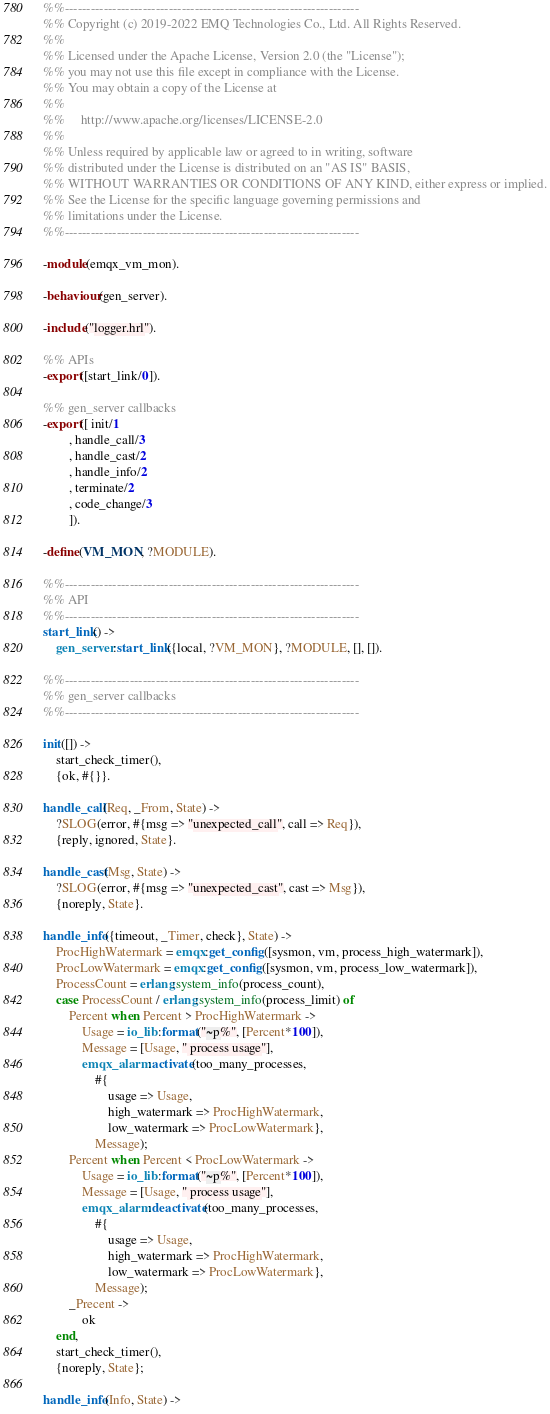Convert code to text. <code><loc_0><loc_0><loc_500><loc_500><_Erlang_>%%--------------------------------------------------------------------
%% Copyright (c) 2019-2022 EMQ Technologies Co., Ltd. All Rights Reserved.
%%
%% Licensed under the Apache License, Version 2.0 (the "License");
%% you may not use this file except in compliance with the License.
%% You may obtain a copy of the License at
%%
%%     http://www.apache.org/licenses/LICENSE-2.0
%%
%% Unless required by applicable law or agreed to in writing, software
%% distributed under the License is distributed on an "AS IS" BASIS,
%% WITHOUT WARRANTIES OR CONDITIONS OF ANY KIND, either express or implied.
%% See the License for the specific language governing permissions and
%% limitations under the License.
%%--------------------------------------------------------------------

-module(emqx_vm_mon).

-behaviour(gen_server).

-include("logger.hrl").

%% APIs
-export([start_link/0]).

%% gen_server callbacks
-export([ init/1
        , handle_call/3
        , handle_cast/2
        , handle_info/2
        , terminate/2
        , code_change/3
        ]).

-define(VM_MON, ?MODULE).

%%--------------------------------------------------------------------
%% API
%%--------------------------------------------------------------------
start_link() ->
    gen_server:start_link({local, ?VM_MON}, ?MODULE, [], []).

%%--------------------------------------------------------------------
%% gen_server callbacks
%%--------------------------------------------------------------------

init([]) ->
    start_check_timer(),
    {ok, #{}}.

handle_call(Req, _From, State) ->
    ?SLOG(error, #{msg => "unexpected_call", call => Req}),
    {reply, ignored, State}.

handle_cast(Msg, State) ->
    ?SLOG(error, #{msg => "unexpected_cast", cast => Msg}),
    {noreply, State}.

handle_info({timeout, _Timer, check}, State) ->
    ProcHighWatermark = emqx:get_config([sysmon, vm, process_high_watermark]),
    ProcLowWatermark = emqx:get_config([sysmon, vm, process_low_watermark]),
    ProcessCount = erlang:system_info(process_count),
    case ProcessCount / erlang:system_info(process_limit) of
        Percent when Percent > ProcHighWatermark ->
            Usage = io_lib:format("~p%", [Percent*100]),
            Message = [Usage, " process usage"],
            emqx_alarm:activate(too_many_processes,
                #{
                    usage => Usage,
                    high_watermark => ProcHighWatermark,
                    low_watermark => ProcLowWatermark},
                Message);
        Percent when Percent < ProcLowWatermark ->
            Usage = io_lib:format("~p%", [Percent*100]),
            Message = [Usage, " process usage"],
            emqx_alarm:deactivate(too_many_processes,
                #{
                    usage => Usage,
                    high_watermark => ProcHighWatermark,
                    low_watermark => ProcLowWatermark},
                Message);
        _Precent ->
            ok
    end,
    start_check_timer(),
    {noreply, State};

handle_info(Info, State) -></code> 